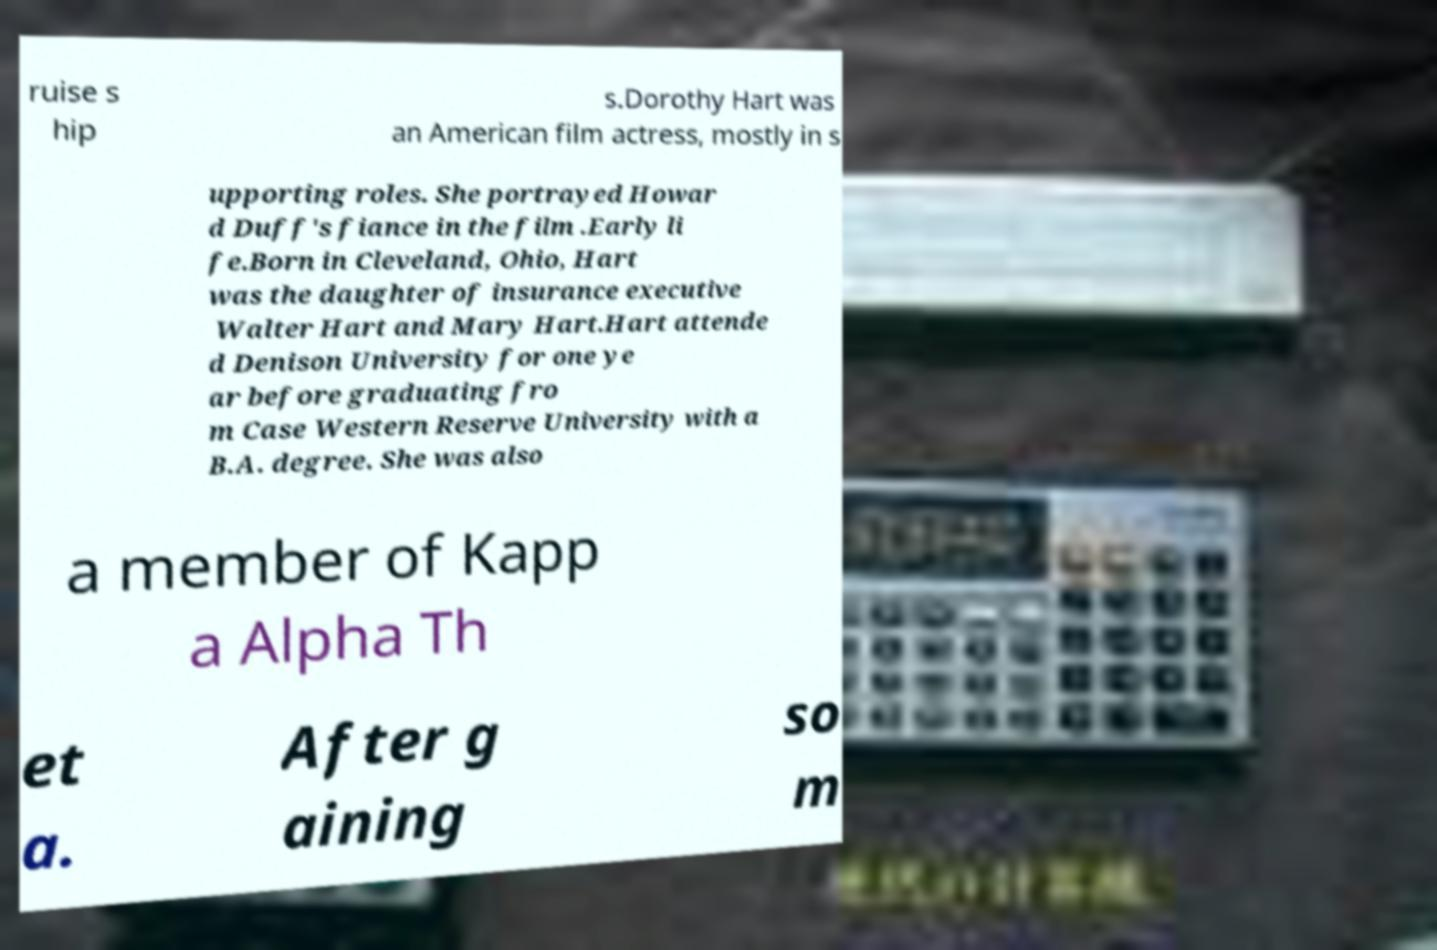Could you extract and type out the text from this image? ruise s hip s.Dorothy Hart was an American film actress, mostly in s upporting roles. She portrayed Howar d Duff's fiance in the film .Early li fe.Born in Cleveland, Ohio, Hart was the daughter of insurance executive Walter Hart and Mary Hart.Hart attende d Denison University for one ye ar before graduating fro m Case Western Reserve University with a B.A. degree. She was also a member of Kapp a Alpha Th et a. After g aining so m 